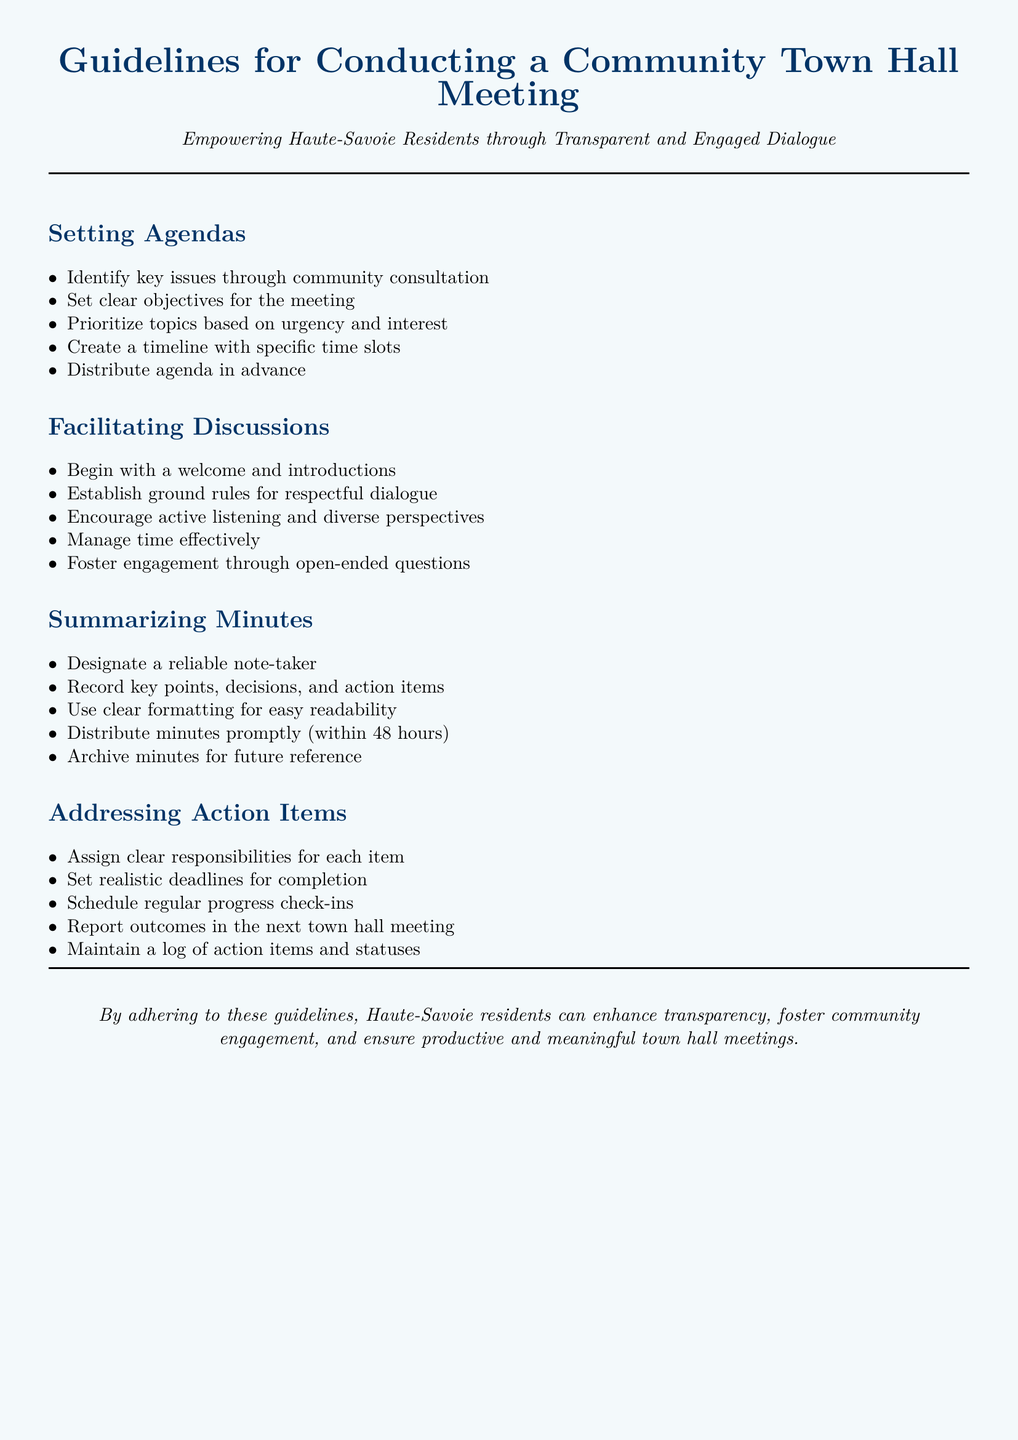What are the key issues identified through community consultation? The key issues are identified as part of setting the agenda for town hall meetings.
Answer: Key issues What is the time frame for distributing meeting minutes? The guidelines state that minutes should be distributed promptly within a specific time frame after the meeting.
Answer: 48 hours Who should take notes during the meeting? There is a recommendation for a specific individual to be responsible for recording minutes.
Answer: A reliable note-taker What type of questions should be encouraged during discussions? The guidelines suggest a particular type of question format to facilitate engagement.
Answer: Open-ended questions How many specific responsibilities should be assigned for action items? This question requires reasoning about the number of steps outlined to ensure accountability.
Answer: Each item What is the purpose of establishing ground rules? Ground rules are important for a specific reason that facilitates the flow of the meeting.
Answer: Respectful dialogue What should be archived for future reference? The guidelines state a particular document type should be maintained for later use.
Answer: Minutes What color is used for the title text? The document specifies a color scheme that includes the title's color.
Answer: Dark blue 